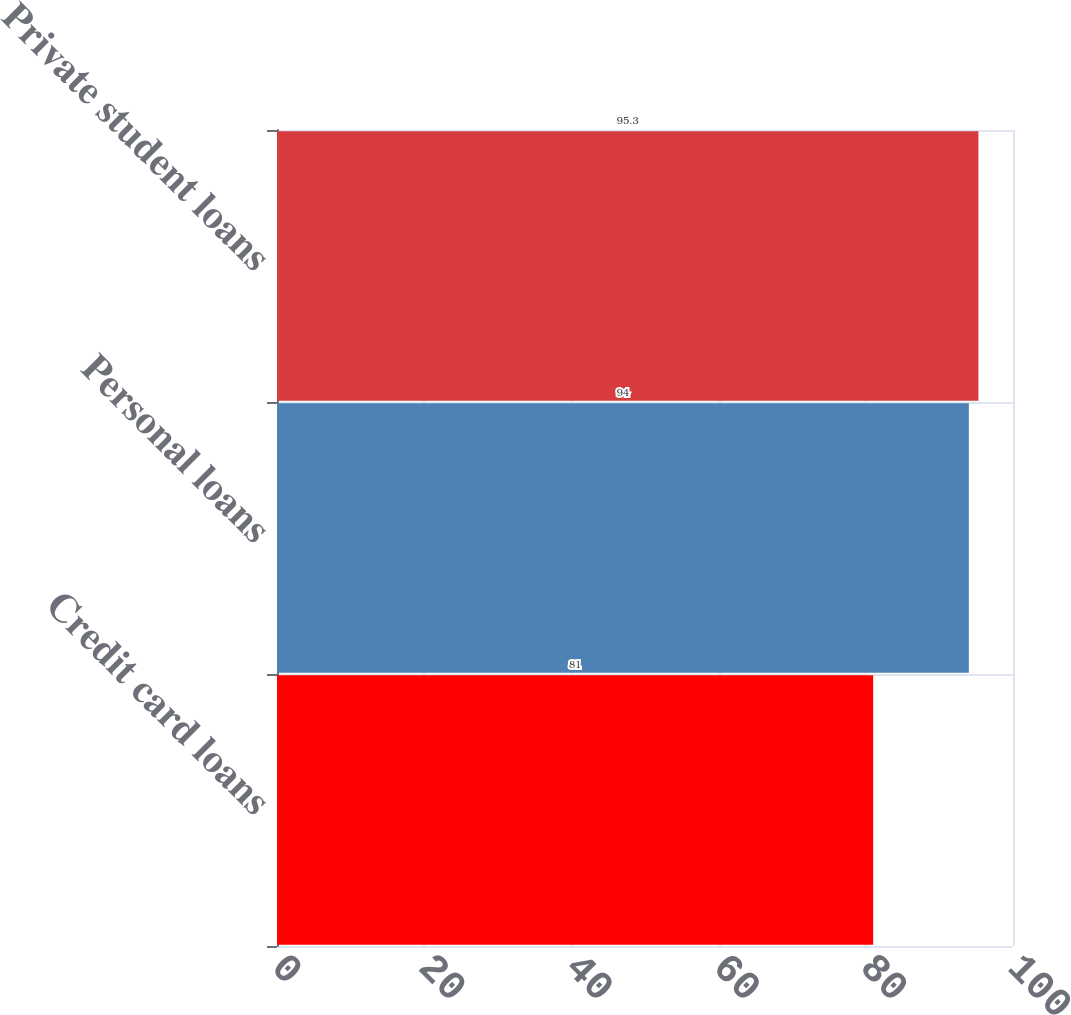<chart> <loc_0><loc_0><loc_500><loc_500><bar_chart><fcel>Credit card loans<fcel>Personal loans<fcel>Private student loans<nl><fcel>81<fcel>94<fcel>95.3<nl></chart> 